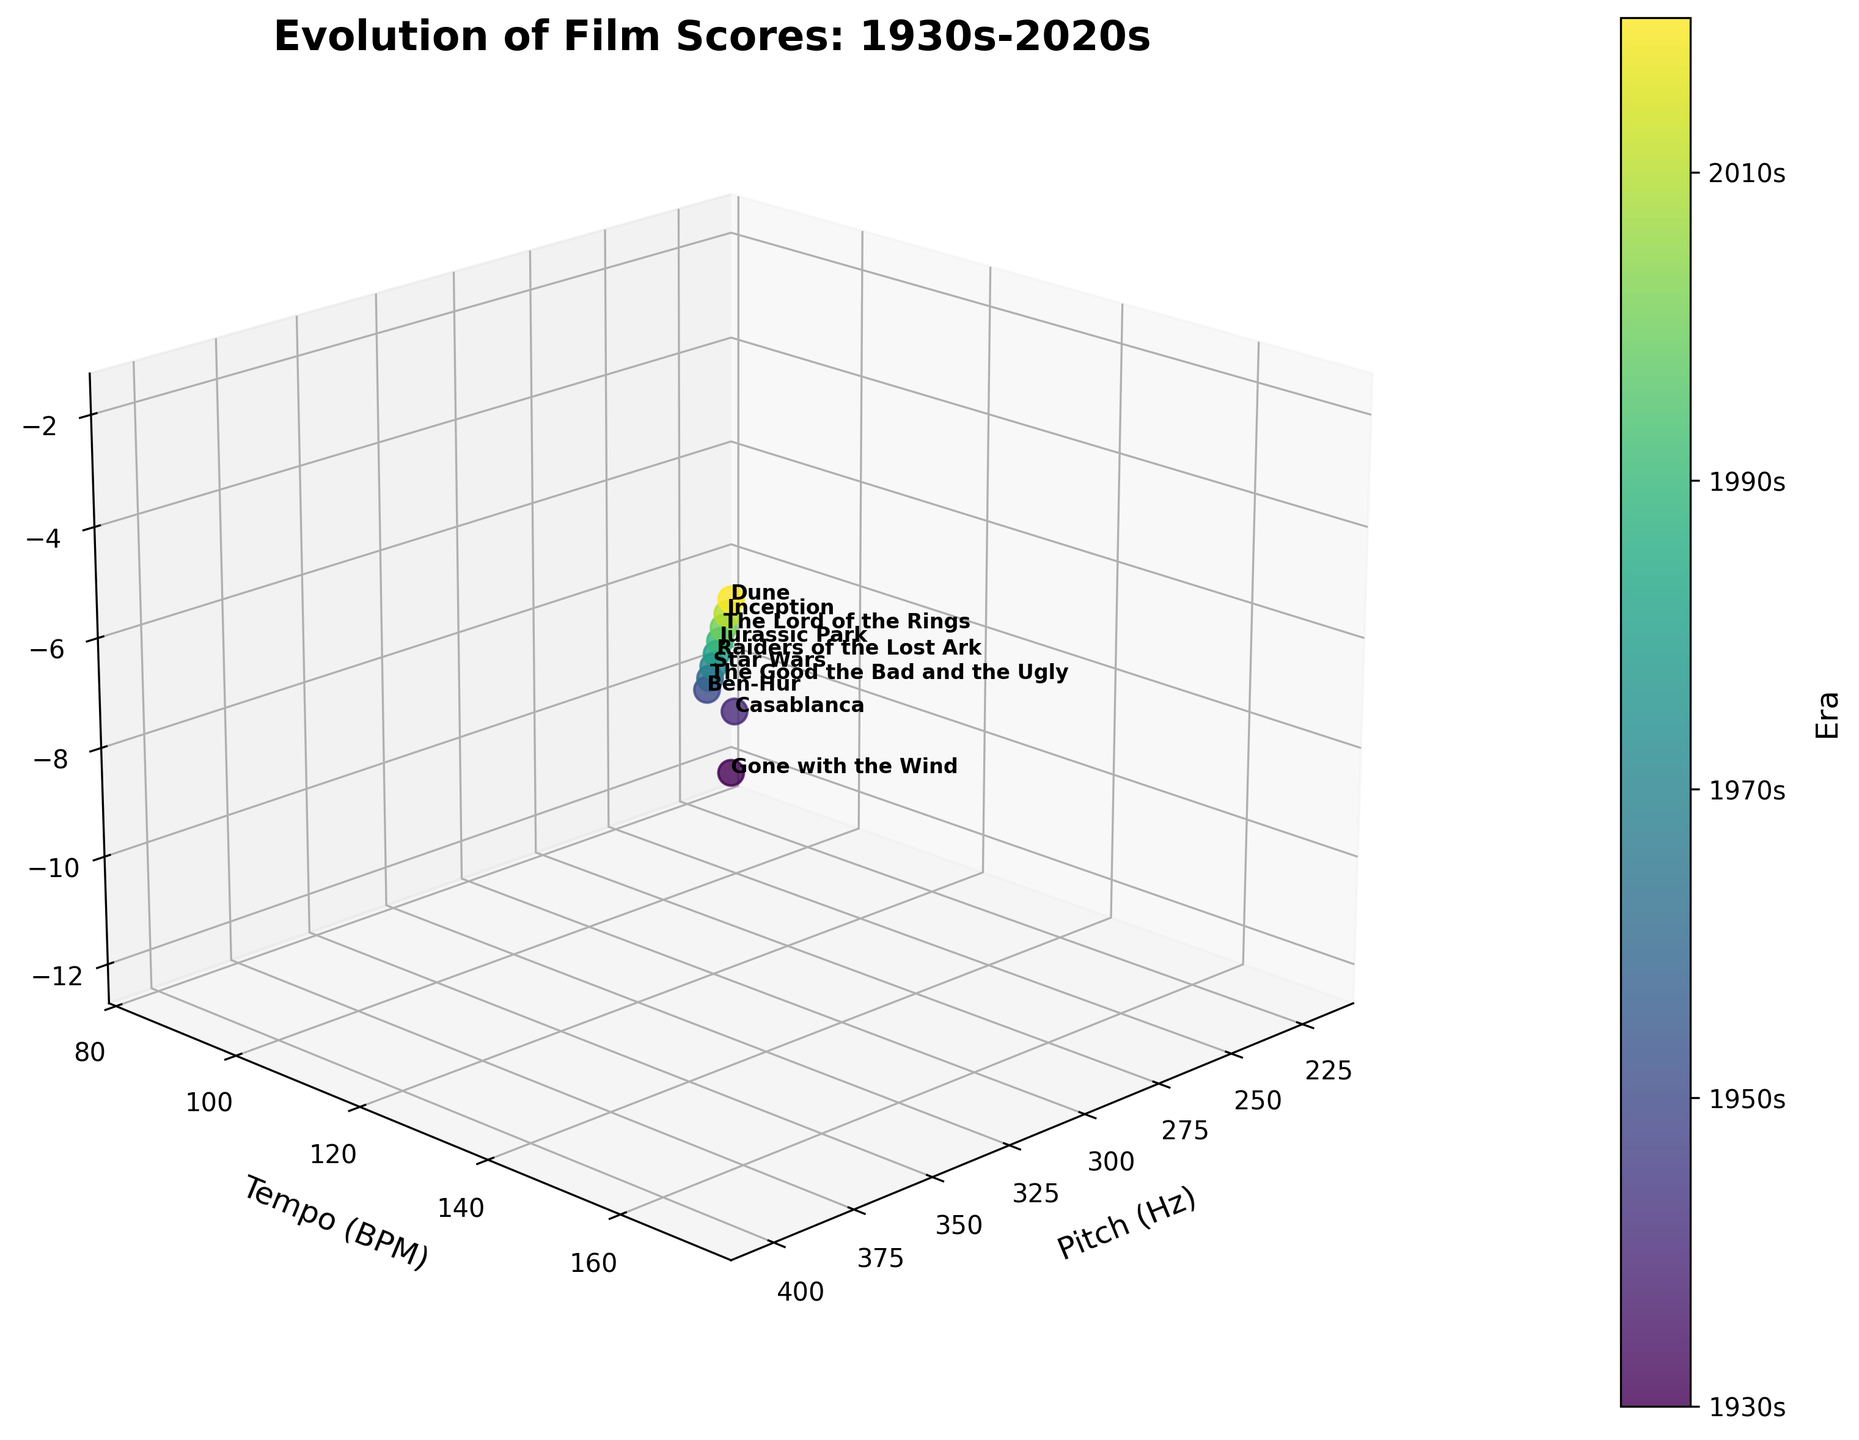How many data points are represented in the figure? Count the number of data points (dots) in the scatter plot, each representing a distinct film score. There are 10 data points, corresponding to the number of films listed from the 1930s to the 2020s.
Answer: 10 What is the title of the figure? Look at the top of the figure where the title is provided. The title is "Evolution of Film Scores: 1930s-2020s."
Answer: Evolution of Film Scores: 1930s-2020s Which film has the highest pitch? Find the data point with the highest value on the x-axis (Pitch in Hz) and note the corresponding film. The highest pitch is 400 Hz, associated with the film "Dune" from the 2020s.
Answer: Dune Compare the loudness of "Star Wars" and "Inception". Which one is louder? Locate the data points for "Star Wars" and "Inception" and compare their z-axis values (Loudness in dB). "Star Wars" has -7 dB, and "Inception" has -3 dB. Since -3 dB is louder than -7 dB, "Inception" is louder.
Answer: Inception What is the average tempo of the films from the 1930s, 1940s, and 1950s? Locate the tempos for the films "Gone with the Wind" (85 BPM), "Casablanca" (95 BPM), and "Ben-Hur" (100 BPM). Calculate the average: (85 + 95 + 100) / 3 = 280 / 3 ≈ 93.33 BPM.
Answer: 93.33 BPM How has the loudness changed from the 1930s to the 2020s? Compare the z-axis values of the data points from the 1930s and the 2020s. The loudness changes from -12 dB for "Gone with the Wind" to -2 dB for "Dune."
Answer: Increased by 10 dB Which era has a film score with a pitch of 260 Hz? Locate the data point on the x-axis with a pitch value of 260 Hz and identify its era. This corresponds to the film "Ben-Hur" from the 1950s.
Answer: 1950s Which film has the fastest tempo? Identify the data point with the highest value on the y-axis (Tempo in BPM). The highest tempo is 170 BPM, corresponding to the film "Dune."
Answer: Dune Is there a trend in the pitch over the decades? Observe the general direction of the data points along the x-axis (Pitch in Hz) from the 1930s to the 2020s. The pitch increases consistently from 220 Hz to 400 Hz over the decades.
Answer: Increasing trend 